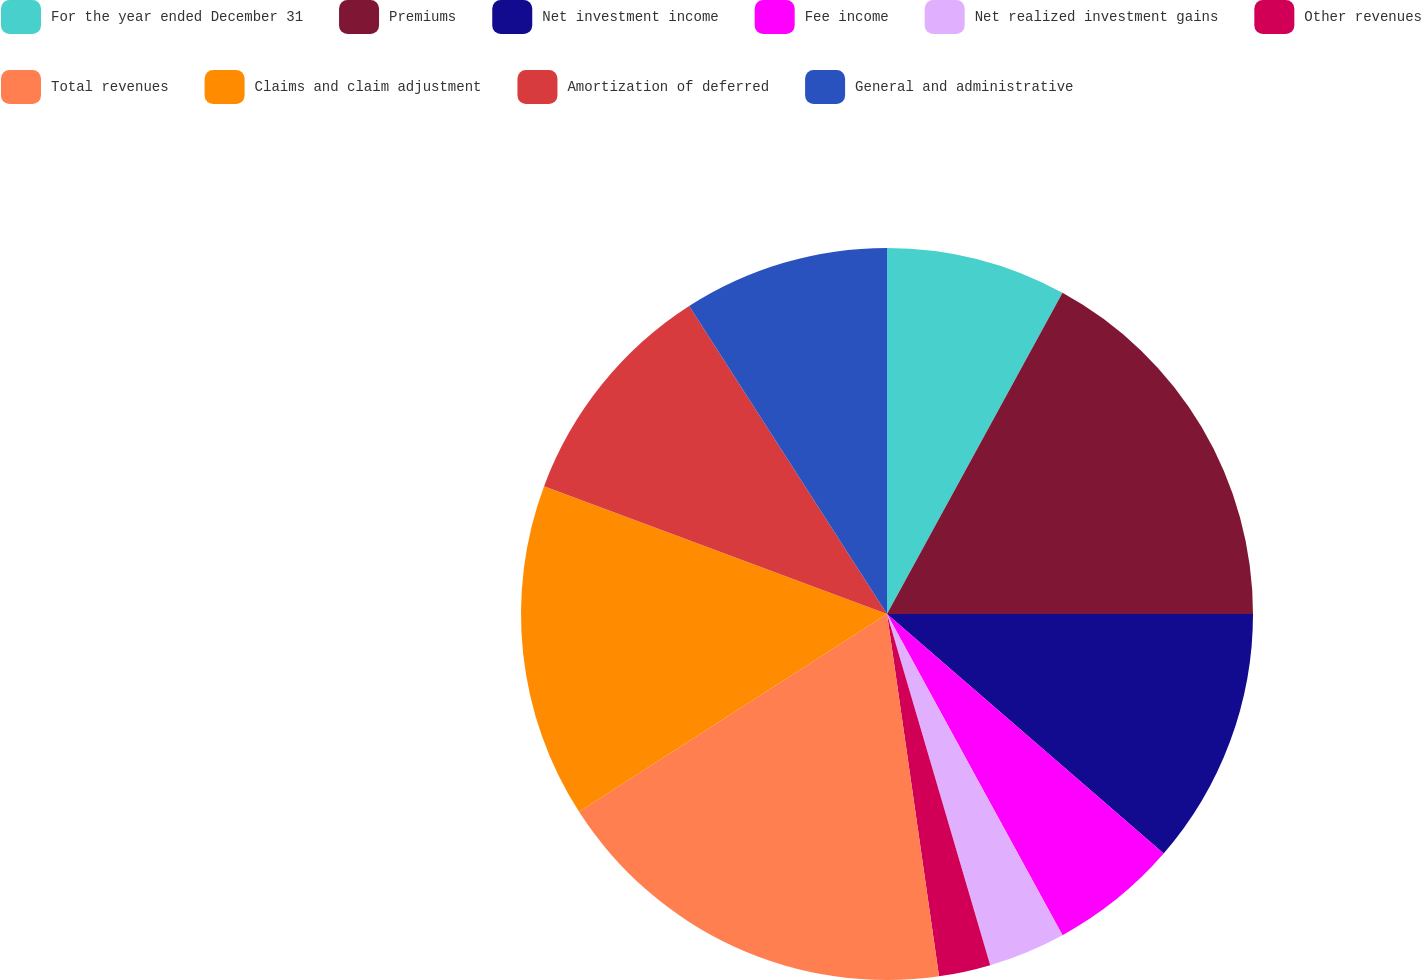Convert chart to OTSL. <chart><loc_0><loc_0><loc_500><loc_500><pie_chart><fcel>For the year ended December 31<fcel>Premiums<fcel>Net investment income<fcel>Fee income<fcel>Net realized investment gains<fcel>Other revenues<fcel>Total revenues<fcel>Claims and claim adjustment<fcel>Amortization of deferred<fcel>General and administrative<nl><fcel>7.96%<fcel>17.04%<fcel>11.36%<fcel>5.68%<fcel>3.41%<fcel>2.28%<fcel>18.18%<fcel>14.77%<fcel>10.23%<fcel>9.09%<nl></chart> 